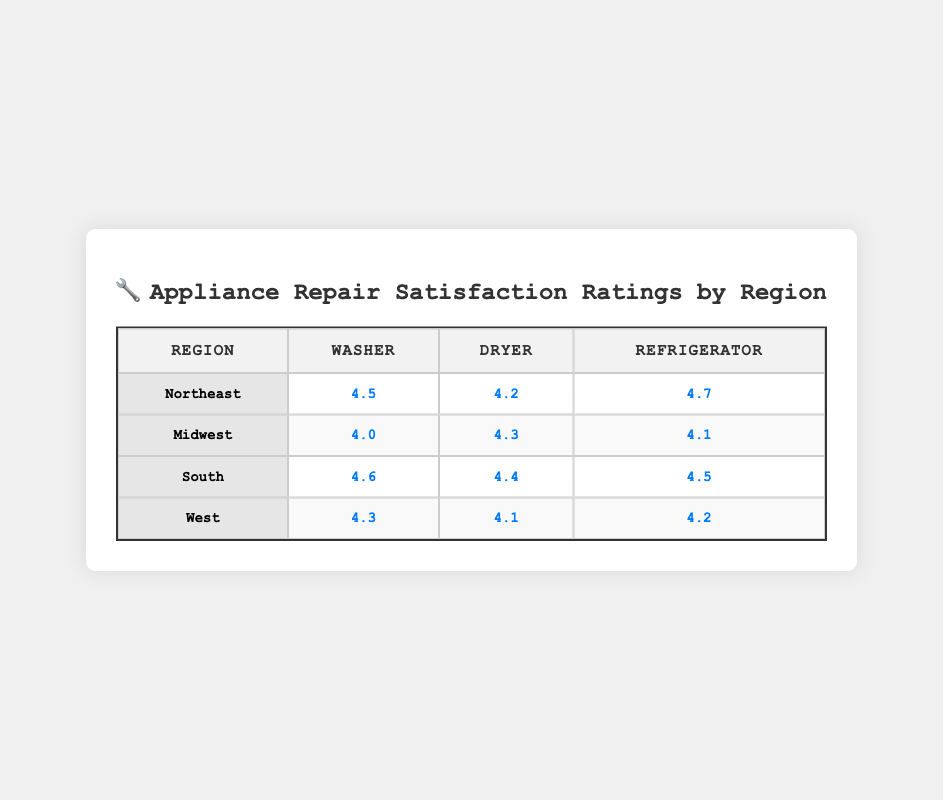What is the satisfaction rating for washers in the South region? The table shows that the satisfaction rating for washers in the South region is clearly listed as 4.6.
Answer: 4.6 What is the highest satisfaction rating for a refrigerator across all regions? By scanning the table, the highest satisfaction rating for a refrigerator is found in the Northeast, which is 4.7.
Answer: 4.7 Which region has the lowest satisfaction rating for dryers? Looking at the ratings for dryers in each region, the West region has the lowest satisfaction rating, which is 4.1.
Answer: 4.1 What is the average satisfaction rating for washers across all regions? The satisfaction ratings for washers are 4.5 (Northeast), 4.0 (Midwest), 4.6 (South), and 4.3 (West). Adding these values gives a total of 17.4, and dividing by the number of regions (4) results in an average rating of 4.35.
Answer: 4.35 Is the satisfaction rating for dryers in the Midwest higher than for refrigerators in the South? The rating for dryers in the Midwest is 4.3, while the rating for refrigerators in the South is 4.5. Since 4.3 is not higher than 4.5, the answer is no.
Answer: No Which appliance repair type has the highest rating in the Northeast region? In the Northeast region, the ratings for each appliance are 4.5 for washers, 4.2 for dryers, and 4.7 for refrigerators. The highest among these is 4.7 for refrigerators.
Answer: Refrigerators What is the difference between the highest and lowest satisfaction ratings for washers? The highest rating for washers is 4.6 (South) and the lowest is 4.0 (Midwest). The difference is calculated as 4.6 - 4.0 = 0.6.
Answer: 0.6 Are satisfaction ratings for refrigerators higher than those for dryers in the South? In the South, the refrigerator has a satisfaction rating of 4.5, while the dryer has a rating of 4.4. Since 4.5 is indeed higher than 4.4, the answer is yes.
Answer: Yes What is the least satisfying appliance repair type in the Midwest region? In the Midwest, the satisfaction ratings are 4.0 for washers, 4.3 for dryers, and 4.1 for refrigerators. The least satisfying rating is 4.0 for washers.
Answer: Washers 